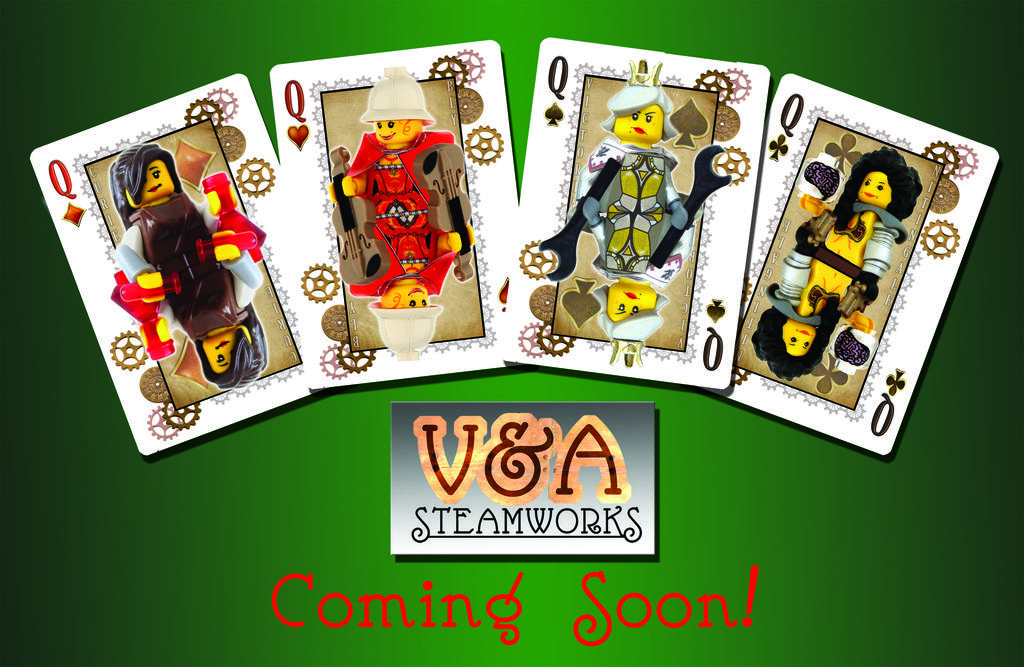What type of playing cards are featured in the image? There are four queen cards in the image. What color is the background of the image? The background of the image is green. What type of jeans are the bears wearing in the image? There are no bears or jeans present in the image; it only features four queen cards against a green background. 